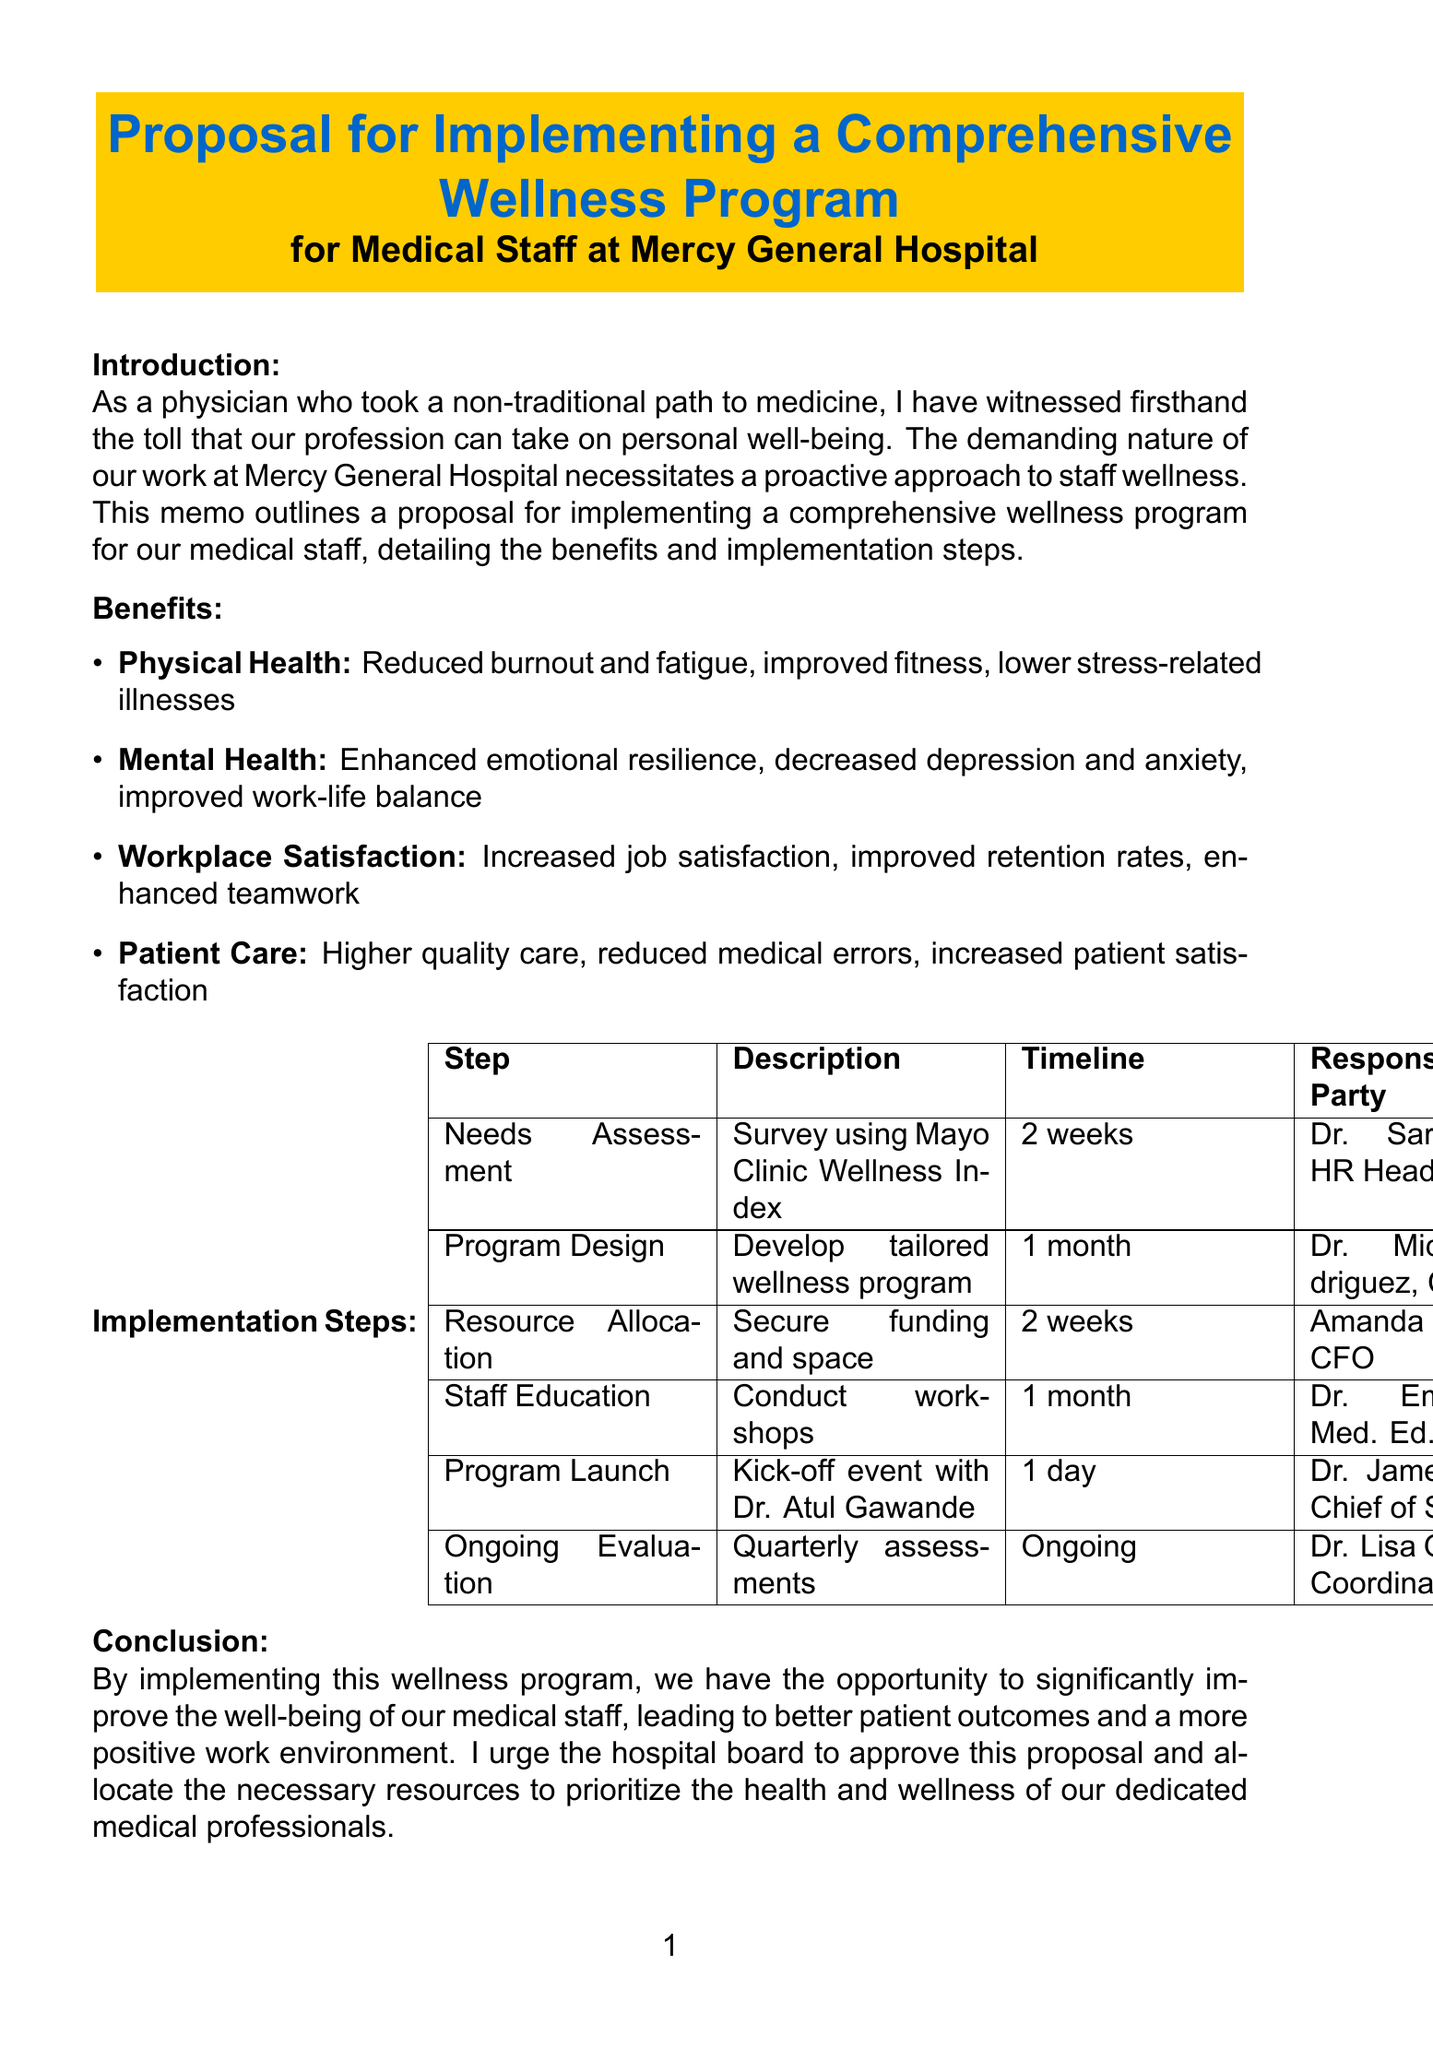What is the title of the memo? The title of the memo is the primary heading in the document that summarizes its purpose, which is about a wellness program.
Answer: Proposal for Implementing a Comprehensive Wellness Program for Medical Staff at Mercy General Hospital Who is responsible for the needs assessment? The needs assessment is the first implementation step, and it specifies who will carry it out.
Answer: Dr. Sarah Chen, Head of Human Resources What is one physical health benefit listed? The document provides examples under different benefit categories; one example under physical health is desired.
Answer: Reduced rates of burnout and fatigue What is the timeline for program design? The timeline indicates how long the program design will take, as mentioned in the implementation steps.
Answer: 1 month Who will lead the staff education workshops? The staff education section names the person responsible for leading the workshops.
Answer: Dr. Emily Tran, Director of Medical Education What is the primary purpose of the memo? The purpose tells the reader the goal of the memo and what it aims to address concerning staff wellness.
Answer: Implementing a comprehensive wellness program for our medical staff What is the final call to action in the conclusion? The conclusion includes a call to action that aims to persuade the audience for a specific outcome.
Answer: Approve this proposal and allocate the necessary resources Which guest speaker is mentioned for the program launch event? The program launch section names a guest speaker who will be featured at the event; it is specifically asked.
Answer: Dr. Atul Gawande 